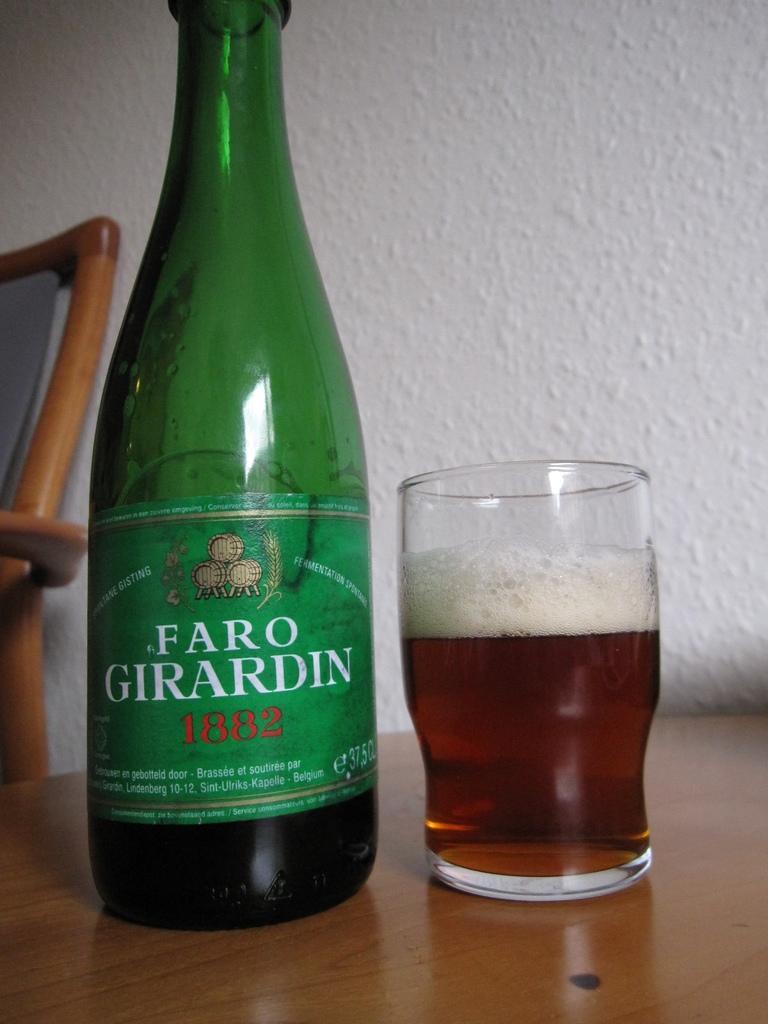Please provide a concise description of this image. There is a bottle and glass of drink on the table and there is a chair beside it and the wall is white in color. 